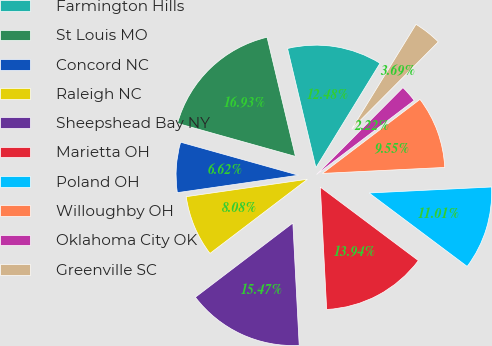<chart> <loc_0><loc_0><loc_500><loc_500><pie_chart><fcel>Farmington Hills<fcel>St Louis MO<fcel>Concord NC<fcel>Raleigh NC<fcel>Sheepshead Bay NY<fcel>Marietta OH<fcel>Poland OH<fcel>Willoughby OH<fcel>Oklahoma City OK<fcel>Greenville SC<nl><fcel>12.48%<fcel>16.93%<fcel>6.62%<fcel>8.08%<fcel>15.47%<fcel>13.94%<fcel>11.01%<fcel>9.55%<fcel>2.22%<fcel>3.69%<nl></chart> 